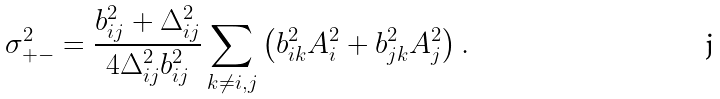<formula> <loc_0><loc_0><loc_500><loc_500>\sigma _ { + - } ^ { 2 } = \frac { b _ { i j } ^ { 2 } + \Delta _ { i j } ^ { 2 } } { 4 \Delta _ { i j } ^ { 2 } b _ { i j } ^ { 2 } } \sum _ { k \neq i , j } \left ( b _ { i k } ^ { 2 } A _ { i } ^ { 2 } + b _ { j k } ^ { 2 } A _ { j } ^ { 2 } \right ) .</formula> 